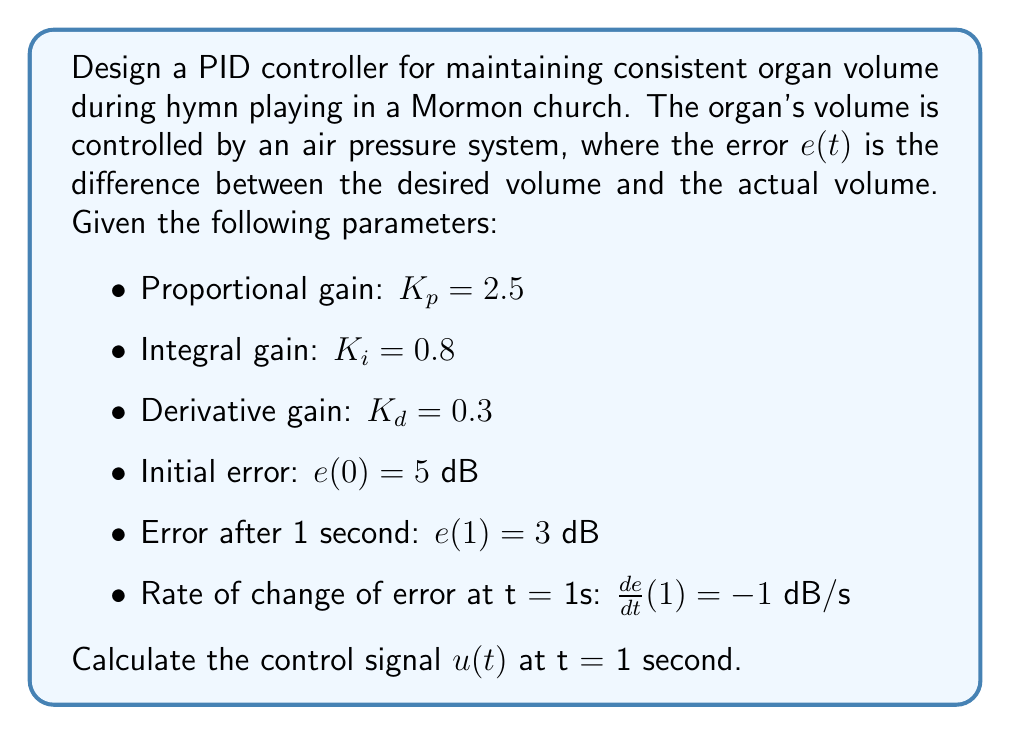Provide a solution to this math problem. To solve this problem, we'll use the PID controller equation and the given parameters. The PID controller equation is:

$$u(t) = K_p e(t) + K_i \int_0^t e(\tau) d\tau + K_d \frac{de(t)}{dt}$$

Let's break down the solution into steps:

1. Proportional term:
   $K_p e(t) = 2.5 \cdot 3 = 7.5$ dB

2. Integral term:
   We need to estimate the integral of the error from 0 to 1 second. We can use the trapezoidal rule for approximation:
   $$\int_0^1 e(\tau) d\tau \approx \frac{1}{2}(e(0) + e(1)) \cdot 1 = \frac{1}{2}(5 + 3) \cdot 1 = 4$$ dB·s
   
   Now, multiply by $K_i$:
   $K_i \int_0^1 e(\tau) d\tau = 0.8 \cdot 4 = 3.2$ dB

3. Derivative term:
   $K_d \frac{de(t)}{dt} = 0.3 \cdot (-1) = -0.3$ dB

4. Sum all terms:
   $u(1) = 7.5 + 3.2 + (-0.3) = 10.4$ dB
Answer: $u(1) = 10.4$ dB 